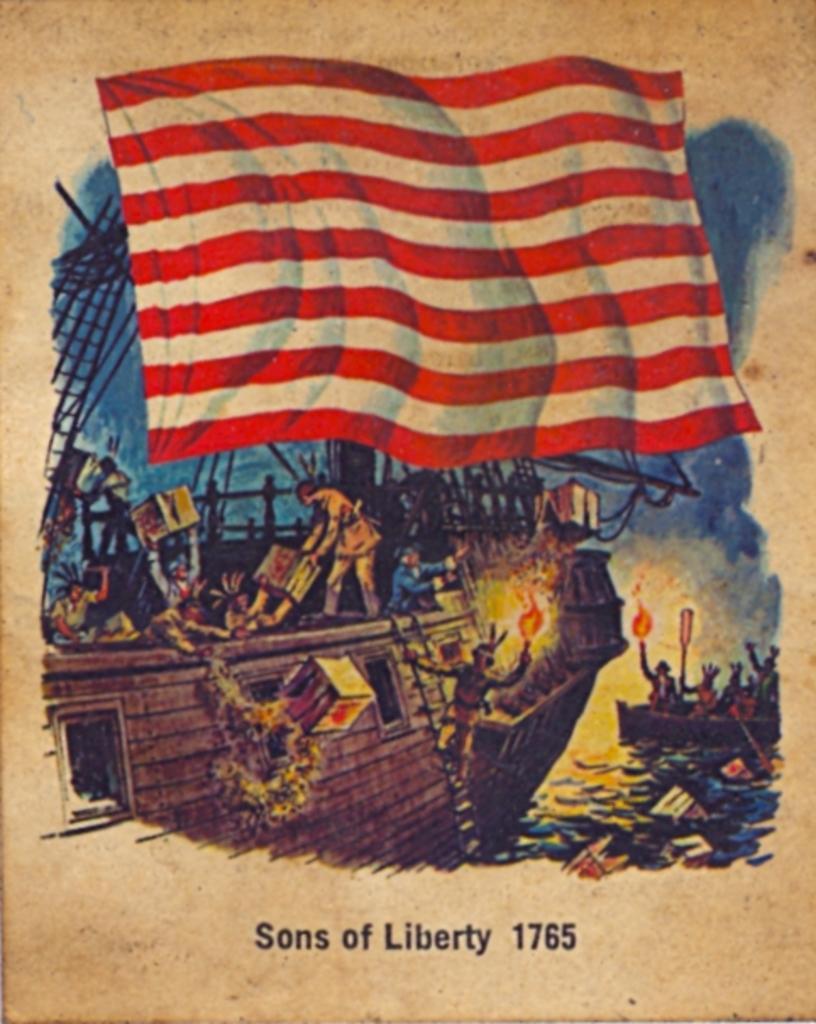How would you summarize this image in a sentence or two? In this image I can see the poster. In the poster I can see two boats and there are few people in the boats. These people are holding the fire, paddles and some boxes. These boots are on the water. I can see the flag in the top which is in red and white color. And I can see the name sons of liberty 1765 is written on the poster. 